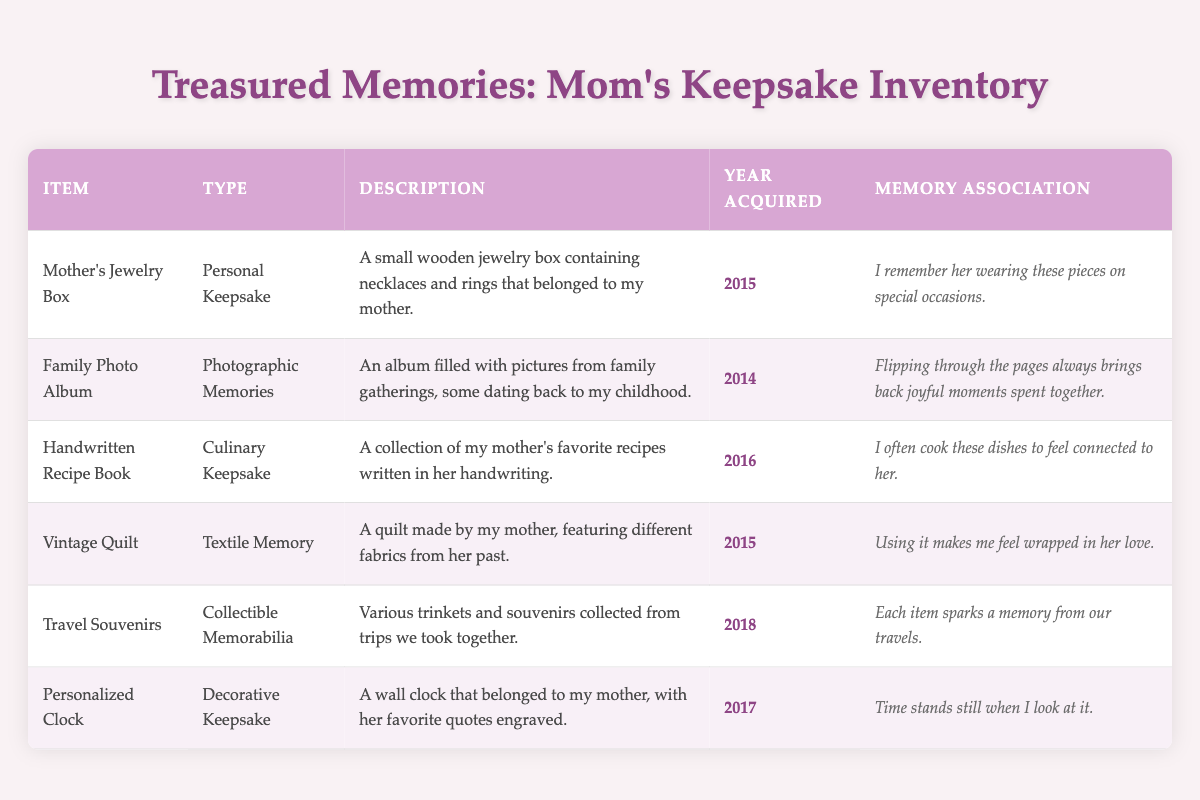What item was acquired in 2014? Referring to the table, the "Family Photo Album" is listed, and the year acquired is specifically mentioned as 2014.
Answer: Family Photo Album How many items were acquired before 2016? By checking the acquisition years, we see that "Family Photo Album" (2014), "Mother's Jewelry Box" (2015), and "Vintage Quilt" (2015) were acquired before 2016. This totals to three items.
Answer: 3 Is the "Vintage Quilt" categorized as a Personal Keepsake? The table lists the "Vintage Quilt" under "Textile Memory," not "Personal Keepsake," making the statement false.
Answer: No What is the memory association with the "Handwritten Recipe Book"? The table provides the memory association for this item as: "I often cook these dishes to feel connected to her."
Answer: I often cook these dishes to feel connected to her How many Culinary Keepsakes are listed in the inventory? The inventory contains one item categorized as a Culinary Keepsake, which is the "Handwritten Recipe Book."
Answer: 1 Which item has a year acquired most recently? Evaluating the years listed, "Travel Souvenirs" (2018) is the most recent acquisition compared to others.
Answer: Travel Souvenirs What item evokes the strongest emotional connection according to its memory association? Based on the descriptions, both "Mother's Jewelry Box" and "Vintage Quilt" are strong candidates, but "Using it makes me feel wrapped in her love." for the quilt suggests a particularly deep emotional connection.
Answer: Vintage Quilt If all items acquired between 2014 and 2017 were to be combined, how many items would there be? The items acquired during that time are: "Family Photo Album" (2014), "Mother's Jewelry Box" (2015), "Vintage Quilt" (2015), "Handwritten Recipe Book" (2016), and "Personalized Clock" (2017). This totals five items.
Answer: 5 Which item features quotes engraved on it? The "Personalized Clock" is described as having her favorite quotes engraved, explicitly providing the answer.
Answer: Personalized Clock 